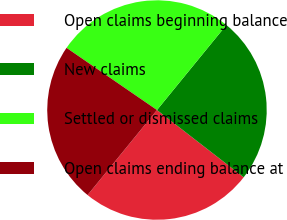Convert chart. <chart><loc_0><loc_0><loc_500><loc_500><pie_chart><fcel>Open claims beginning balance<fcel>New claims<fcel>Settled or dismissed claims<fcel>Open claims ending balance at<nl><fcel>25.4%<fcel>24.6%<fcel>26.31%<fcel>23.69%<nl></chart> 